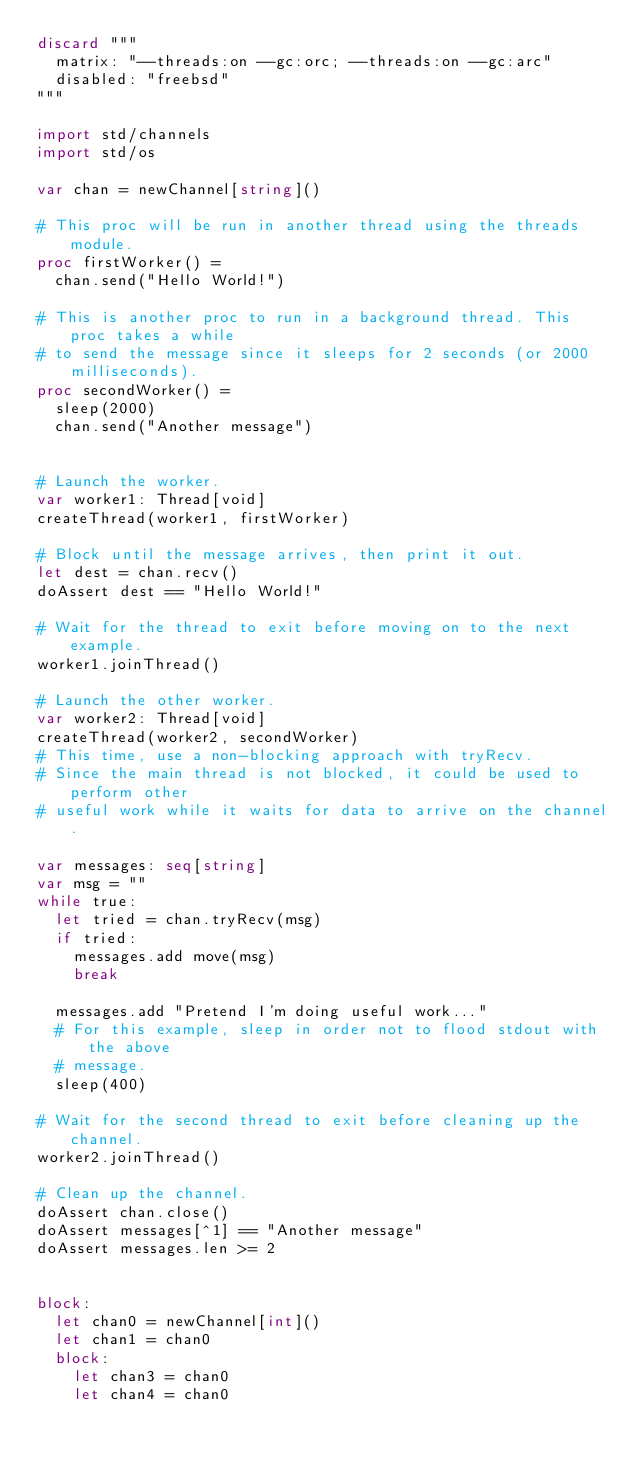Convert code to text. <code><loc_0><loc_0><loc_500><loc_500><_Nim_>discard """
  matrix: "--threads:on --gc:orc; --threads:on --gc:arc"
  disabled: "freebsd"
"""

import std/channels
import std/os

var chan = newChannel[string]()

# This proc will be run in another thread using the threads module.
proc firstWorker() =
  chan.send("Hello World!")

# This is another proc to run in a background thread. This proc takes a while
# to send the message since it sleeps for 2 seconds (or 2000 milliseconds).
proc secondWorker() =
  sleep(2000)
  chan.send("Another message")


# Launch the worker.
var worker1: Thread[void]
createThread(worker1, firstWorker)

# Block until the message arrives, then print it out.
let dest = chan.recv()
doAssert dest == "Hello World!"

# Wait for the thread to exit before moving on to the next example.
worker1.joinThread()

# Launch the other worker.
var worker2: Thread[void]
createThread(worker2, secondWorker)
# This time, use a non-blocking approach with tryRecv.
# Since the main thread is not blocked, it could be used to perform other
# useful work while it waits for data to arrive on the channel.

var messages: seq[string]
var msg = ""
while true:
  let tried = chan.tryRecv(msg)
  if tried:
    messages.add move(msg)
    break
  
  messages.add "Pretend I'm doing useful work..."
  # For this example, sleep in order not to flood stdout with the above
  # message.
  sleep(400)

# Wait for the second thread to exit before cleaning up the channel.
worker2.joinThread()

# Clean up the channel.
doAssert chan.close()
doAssert messages[^1] == "Another message"
doAssert messages.len >= 2


block:
  let chan0 = newChannel[int]()
  let chan1 = chan0
  block:
    let chan3 = chan0
    let chan4 = chan0
</code> 